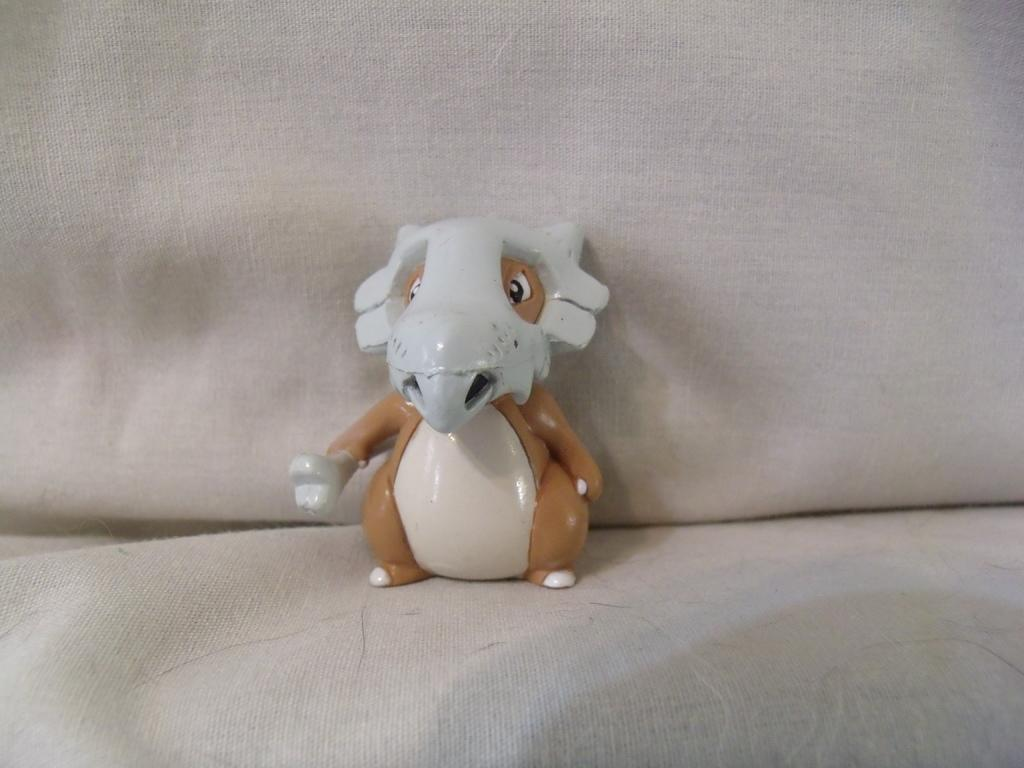What type of object is in the image? There is a plastic toy in the image. What kind of animal does the toy represent? The toy is of an animal. Where is the toy located in the image? The toy is on a sofa. What type of toothpaste is used to clean the toy in the image? There is no toothpaste present in the image, and the toy does not require cleaning. 